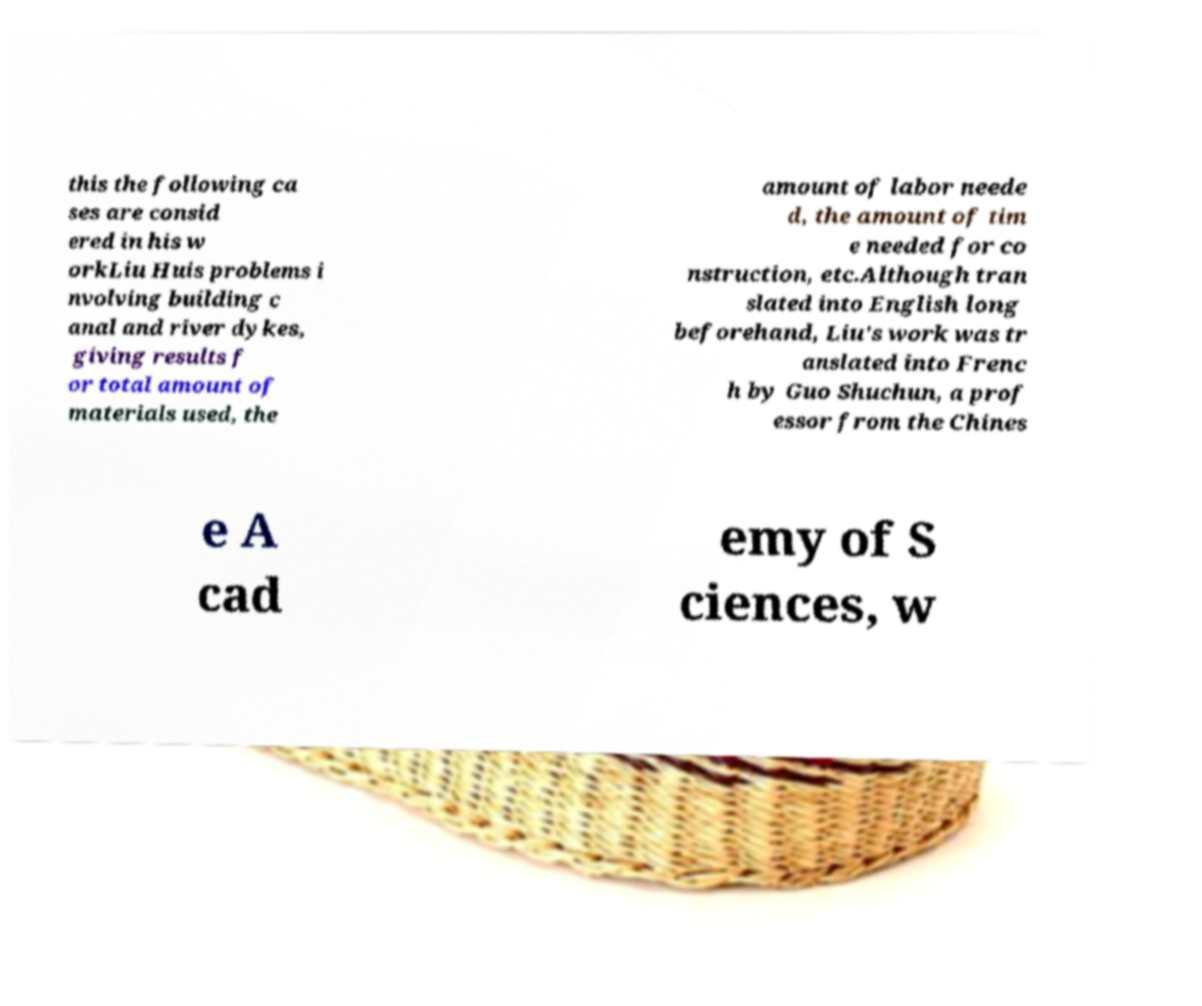Please read and relay the text visible in this image. What does it say? this the following ca ses are consid ered in his w orkLiu Huis problems i nvolving building c anal and river dykes, giving results f or total amount of materials used, the amount of labor neede d, the amount of tim e needed for co nstruction, etc.Although tran slated into English long beforehand, Liu's work was tr anslated into Frenc h by Guo Shuchun, a prof essor from the Chines e A cad emy of S ciences, w 